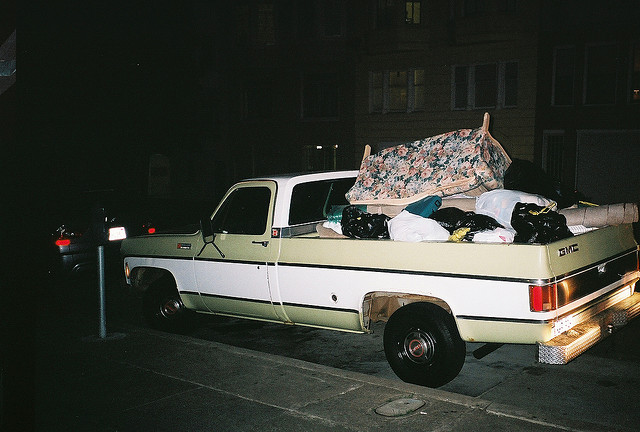Read and extract the text from this image. GMC 